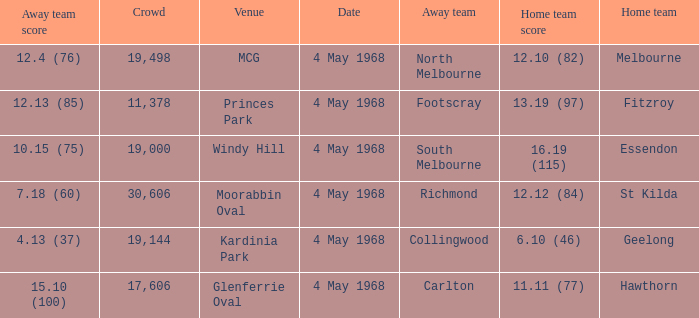What away team played at Kardinia Park? 4.13 (37). Write the full table. {'header': ['Away team score', 'Crowd', 'Venue', 'Date', 'Away team', 'Home team score', 'Home team'], 'rows': [['12.4 (76)', '19,498', 'MCG', '4 May 1968', 'North Melbourne', '12.10 (82)', 'Melbourne'], ['12.13 (85)', '11,378', 'Princes Park', '4 May 1968', 'Footscray', '13.19 (97)', 'Fitzroy'], ['10.15 (75)', '19,000', 'Windy Hill', '4 May 1968', 'South Melbourne', '16.19 (115)', 'Essendon'], ['7.18 (60)', '30,606', 'Moorabbin Oval', '4 May 1968', 'Richmond', '12.12 (84)', 'St Kilda'], ['4.13 (37)', '19,144', 'Kardinia Park', '4 May 1968', 'Collingwood', '6.10 (46)', 'Geelong'], ['15.10 (100)', '17,606', 'Glenferrie Oval', '4 May 1968', 'Carlton', '11.11 (77)', 'Hawthorn']]} 